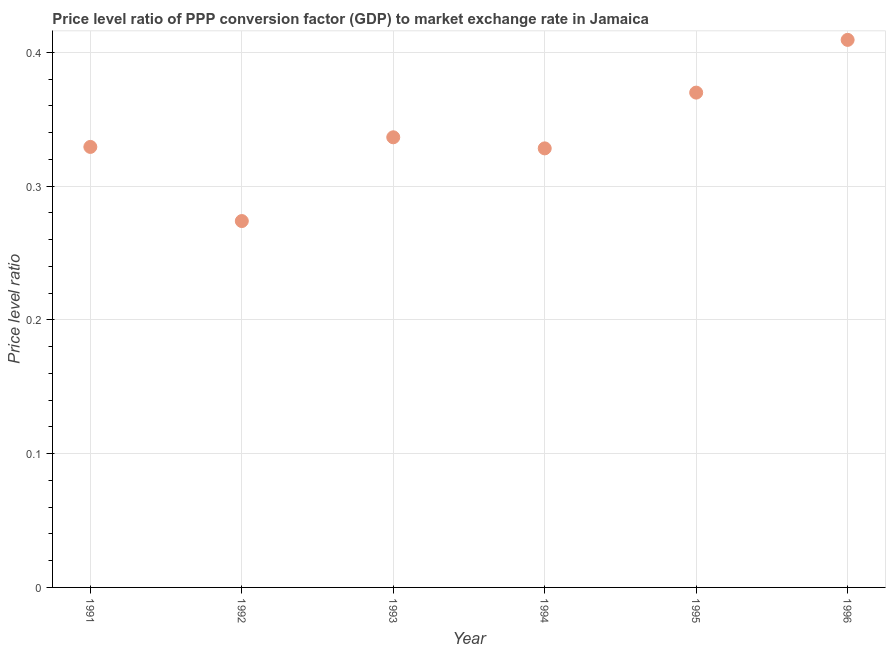What is the price level ratio in 1994?
Give a very brief answer. 0.33. Across all years, what is the maximum price level ratio?
Your response must be concise. 0.41. Across all years, what is the minimum price level ratio?
Provide a succinct answer. 0.27. What is the sum of the price level ratio?
Provide a short and direct response. 2.05. What is the difference between the price level ratio in 1994 and 1996?
Ensure brevity in your answer.  -0.08. What is the average price level ratio per year?
Offer a terse response. 0.34. What is the median price level ratio?
Your answer should be compact. 0.33. In how many years, is the price level ratio greater than 0.24000000000000002 ?
Provide a succinct answer. 6. Do a majority of the years between 1992 and 1991 (inclusive) have price level ratio greater than 0.36000000000000004 ?
Ensure brevity in your answer.  No. What is the ratio of the price level ratio in 1991 to that in 1992?
Your answer should be compact. 1.2. What is the difference between the highest and the second highest price level ratio?
Ensure brevity in your answer.  0.04. What is the difference between the highest and the lowest price level ratio?
Your response must be concise. 0.14. Does the price level ratio monotonically increase over the years?
Make the answer very short. No. Are the values on the major ticks of Y-axis written in scientific E-notation?
Ensure brevity in your answer.  No. Does the graph contain grids?
Offer a very short reply. Yes. What is the title of the graph?
Offer a very short reply. Price level ratio of PPP conversion factor (GDP) to market exchange rate in Jamaica. What is the label or title of the Y-axis?
Provide a short and direct response. Price level ratio. What is the Price level ratio in 1991?
Provide a succinct answer. 0.33. What is the Price level ratio in 1992?
Your answer should be compact. 0.27. What is the Price level ratio in 1993?
Offer a very short reply. 0.34. What is the Price level ratio in 1994?
Keep it short and to the point. 0.33. What is the Price level ratio in 1995?
Provide a short and direct response. 0.37. What is the Price level ratio in 1996?
Give a very brief answer. 0.41. What is the difference between the Price level ratio in 1991 and 1992?
Ensure brevity in your answer.  0.06. What is the difference between the Price level ratio in 1991 and 1993?
Ensure brevity in your answer.  -0.01. What is the difference between the Price level ratio in 1991 and 1994?
Offer a terse response. 0. What is the difference between the Price level ratio in 1991 and 1995?
Offer a very short reply. -0.04. What is the difference between the Price level ratio in 1991 and 1996?
Provide a short and direct response. -0.08. What is the difference between the Price level ratio in 1992 and 1993?
Provide a short and direct response. -0.06. What is the difference between the Price level ratio in 1992 and 1994?
Offer a very short reply. -0.05. What is the difference between the Price level ratio in 1992 and 1995?
Your answer should be compact. -0.1. What is the difference between the Price level ratio in 1992 and 1996?
Ensure brevity in your answer.  -0.14. What is the difference between the Price level ratio in 1993 and 1994?
Provide a succinct answer. 0.01. What is the difference between the Price level ratio in 1993 and 1995?
Keep it short and to the point. -0.03. What is the difference between the Price level ratio in 1993 and 1996?
Give a very brief answer. -0.07. What is the difference between the Price level ratio in 1994 and 1995?
Keep it short and to the point. -0.04. What is the difference between the Price level ratio in 1994 and 1996?
Provide a succinct answer. -0.08. What is the difference between the Price level ratio in 1995 and 1996?
Offer a terse response. -0.04. What is the ratio of the Price level ratio in 1991 to that in 1992?
Provide a short and direct response. 1.2. What is the ratio of the Price level ratio in 1991 to that in 1994?
Your response must be concise. 1. What is the ratio of the Price level ratio in 1991 to that in 1995?
Provide a succinct answer. 0.89. What is the ratio of the Price level ratio in 1991 to that in 1996?
Your answer should be compact. 0.81. What is the ratio of the Price level ratio in 1992 to that in 1993?
Your answer should be very brief. 0.81. What is the ratio of the Price level ratio in 1992 to that in 1994?
Provide a succinct answer. 0.83. What is the ratio of the Price level ratio in 1992 to that in 1995?
Provide a succinct answer. 0.74. What is the ratio of the Price level ratio in 1992 to that in 1996?
Make the answer very short. 0.67. What is the ratio of the Price level ratio in 1993 to that in 1994?
Keep it short and to the point. 1.02. What is the ratio of the Price level ratio in 1993 to that in 1995?
Give a very brief answer. 0.91. What is the ratio of the Price level ratio in 1993 to that in 1996?
Offer a very short reply. 0.82. What is the ratio of the Price level ratio in 1994 to that in 1995?
Your answer should be very brief. 0.89. What is the ratio of the Price level ratio in 1994 to that in 1996?
Your response must be concise. 0.8. What is the ratio of the Price level ratio in 1995 to that in 1996?
Offer a very short reply. 0.9. 